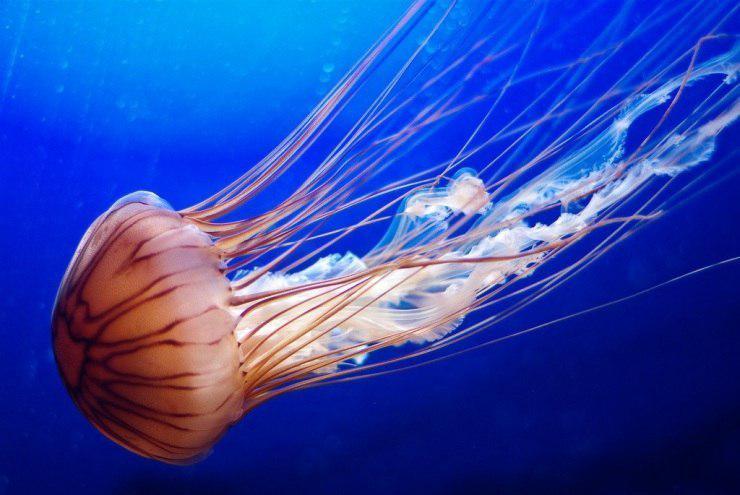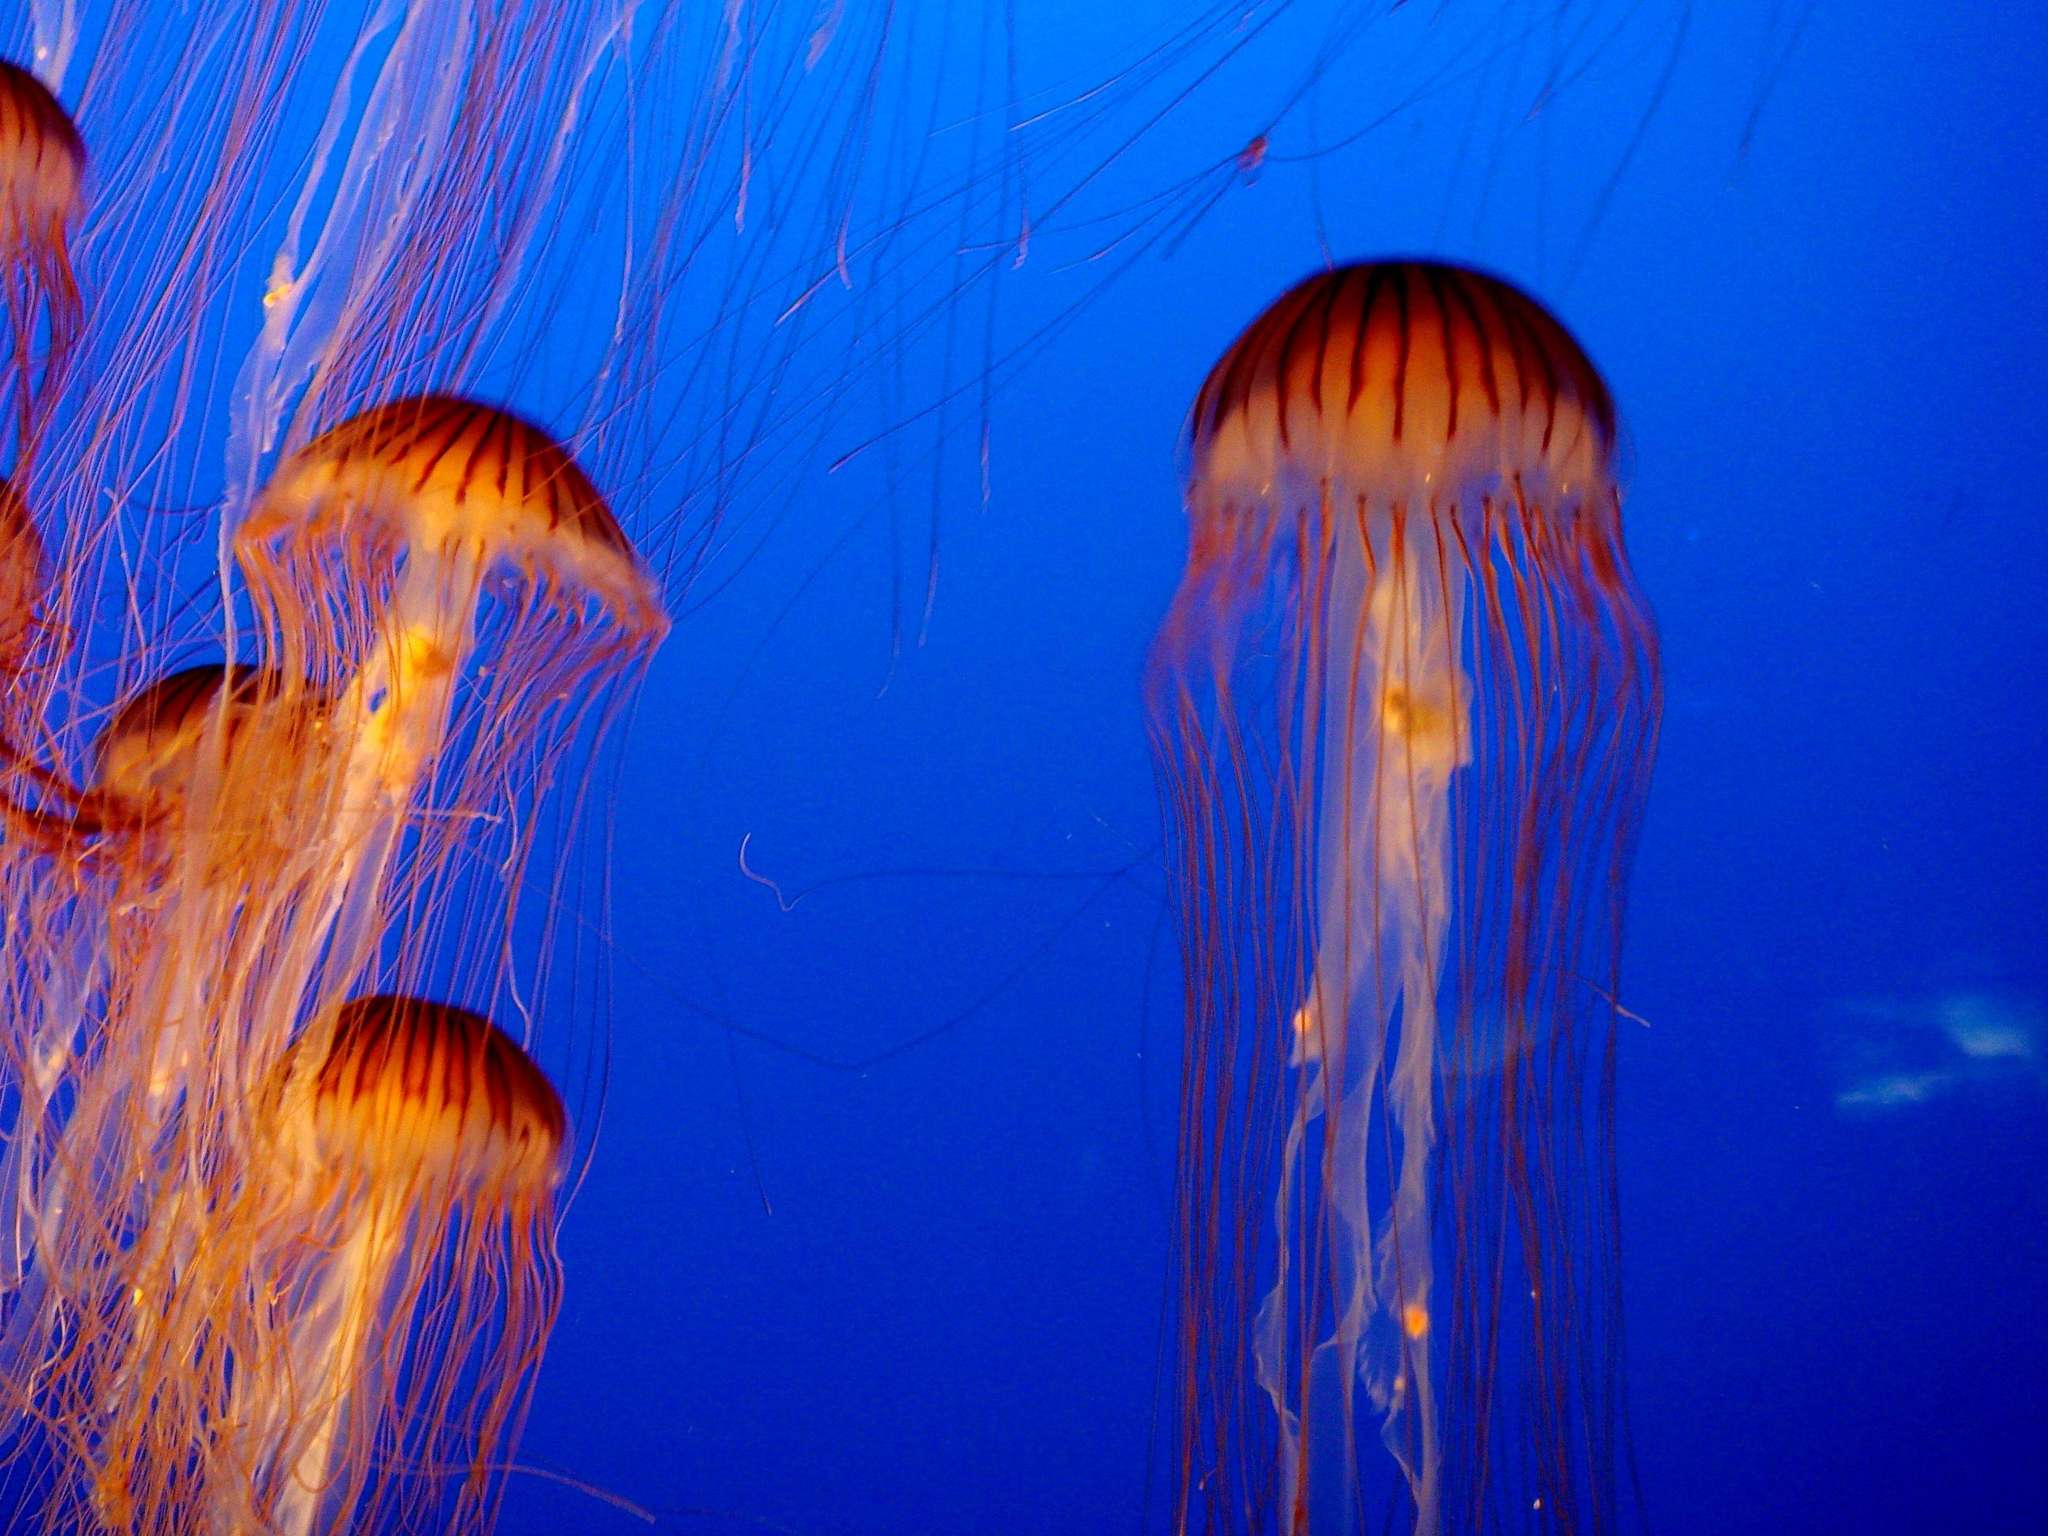The first image is the image on the left, the second image is the image on the right. Examine the images to the left and right. Is the description "The right image shows at least one vivid orange jellyfish." accurate? Answer yes or no. Yes. 